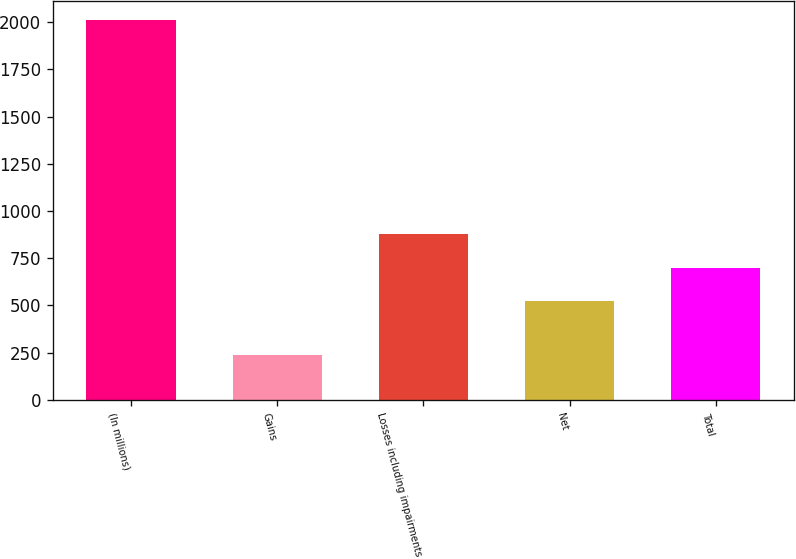Convert chart. <chart><loc_0><loc_0><loc_500><loc_500><bar_chart><fcel>(In millions)<fcel>Gains<fcel>Losses including impairments<fcel>Net<fcel>Total<nl><fcel>2013<fcel>239<fcel>877.8<fcel>523<fcel>700.4<nl></chart> 